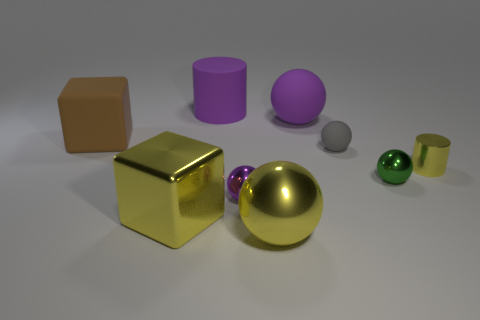How many other things are there of the same color as the big matte sphere?
Keep it short and to the point. 2. There is a purple sphere left of the big ball that is in front of the yellow cylinder; what number of small green metallic objects are left of it?
Your answer should be compact. 0. There is another big object that is the same shape as the big brown thing; what is its color?
Provide a succinct answer. Yellow. Are there any other things that have the same shape as the brown thing?
Your response must be concise. Yes. How many spheres are either small yellow objects or green things?
Your answer should be compact. 1. What is the shape of the gray thing?
Provide a succinct answer. Sphere. There is a small green metallic sphere; are there any small shiny things behind it?
Your response must be concise. Yes. Is the tiny gray ball made of the same material as the small object to the right of the tiny green metal thing?
Provide a succinct answer. No. There is a big rubber object on the left side of the rubber cylinder; is it the same shape as the tiny yellow metallic object?
Your answer should be compact. No. What number of purple balls have the same material as the big brown object?
Provide a succinct answer. 1. 